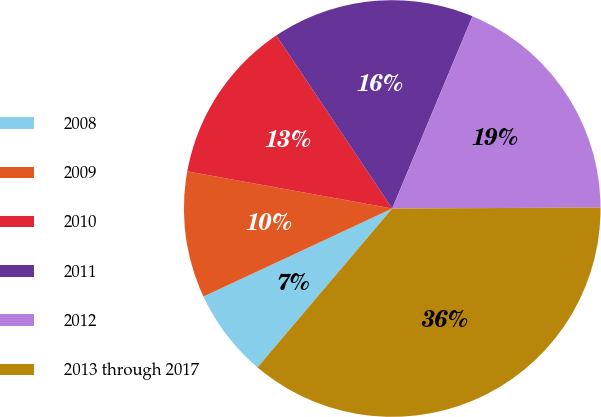Convert chart to OTSL. <chart><loc_0><loc_0><loc_500><loc_500><pie_chart><fcel>2008<fcel>2009<fcel>2010<fcel>2011<fcel>2012<fcel>2013 through 2017<nl><fcel>6.86%<fcel>9.8%<fcel>12.75%<fcel>15.69%<fcel>18.63%<fcel>36.27%<nl></chart> 